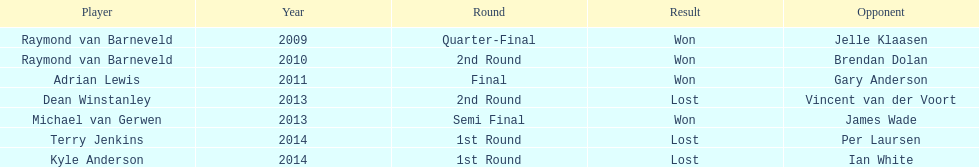Out of the listed players, who are the only ones that played in 2011? Adrian Lewis. 